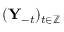Convert formula to latex. <formula><loc_0><loc_0><loc_500><loc_500>( Y _ { - t } ) _ { t \in \mathbb { Z } }</formula> 